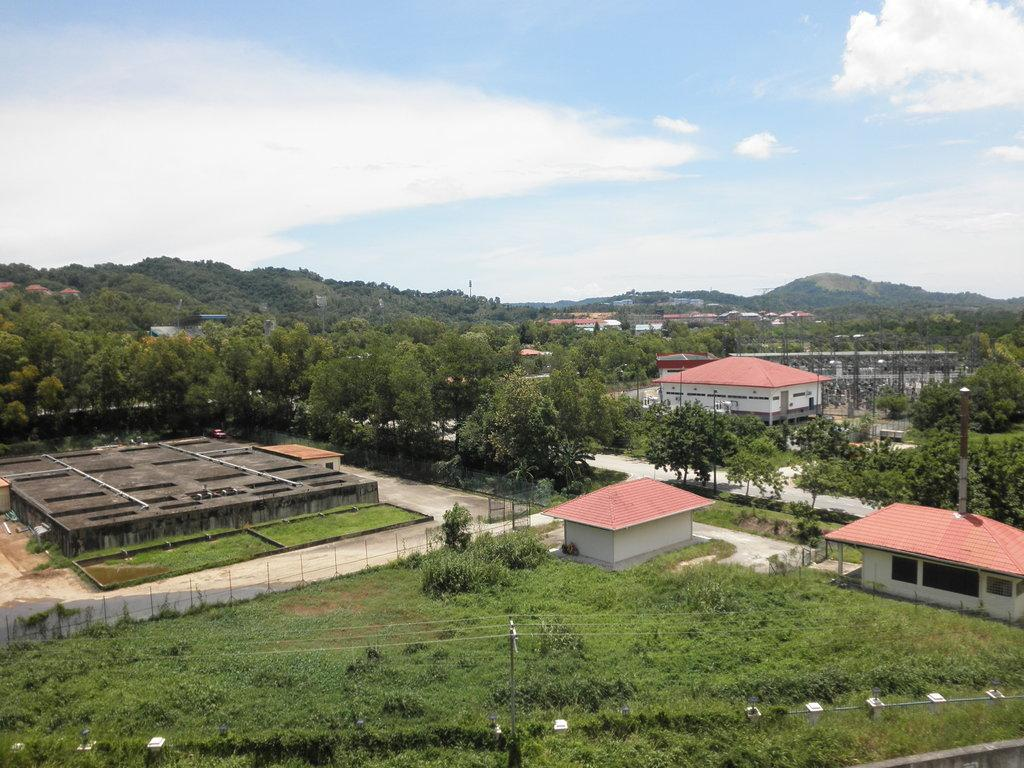What type of vegetation is present on the ground in the center of the image? There is grass on the ground in the center of the image. What type of structures can be seen in the image? There are buildings in the image. What can be seen in the background of the image? There are trees in the background of the image. How would you describe the sky in the image? The sky is cloudy in the background of the image. What type of division is taking place in the image? There is no division taking place in the image; it is a scene with grass, buildings, trees, and a cloudy sky. What type of learning can be observed in the image? There is no learning taking place in the image; it is a scene with grass, buildings, trees, and a cloudy sky. 